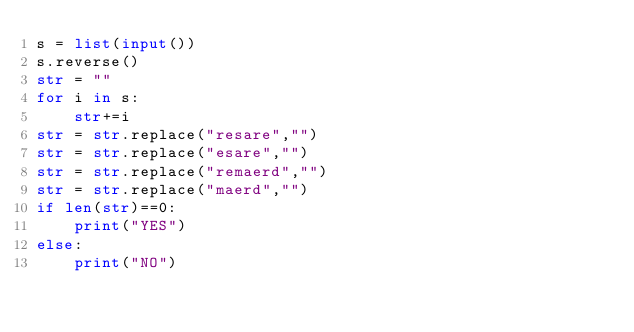Convert code to text. <code><loc_0><loc_0><loc_500><loc_500><_Python_>s = list(input())
s.reverse()
str = ""
for i in s:
    str+=i
str = str.replace("resare","")
str = str.replace("esare","")
str = str.replace("remaerd","")
str = str.replace("maerd","")
if len(str)==0:
    print("YES")
else:
    print("NO")
</code> 